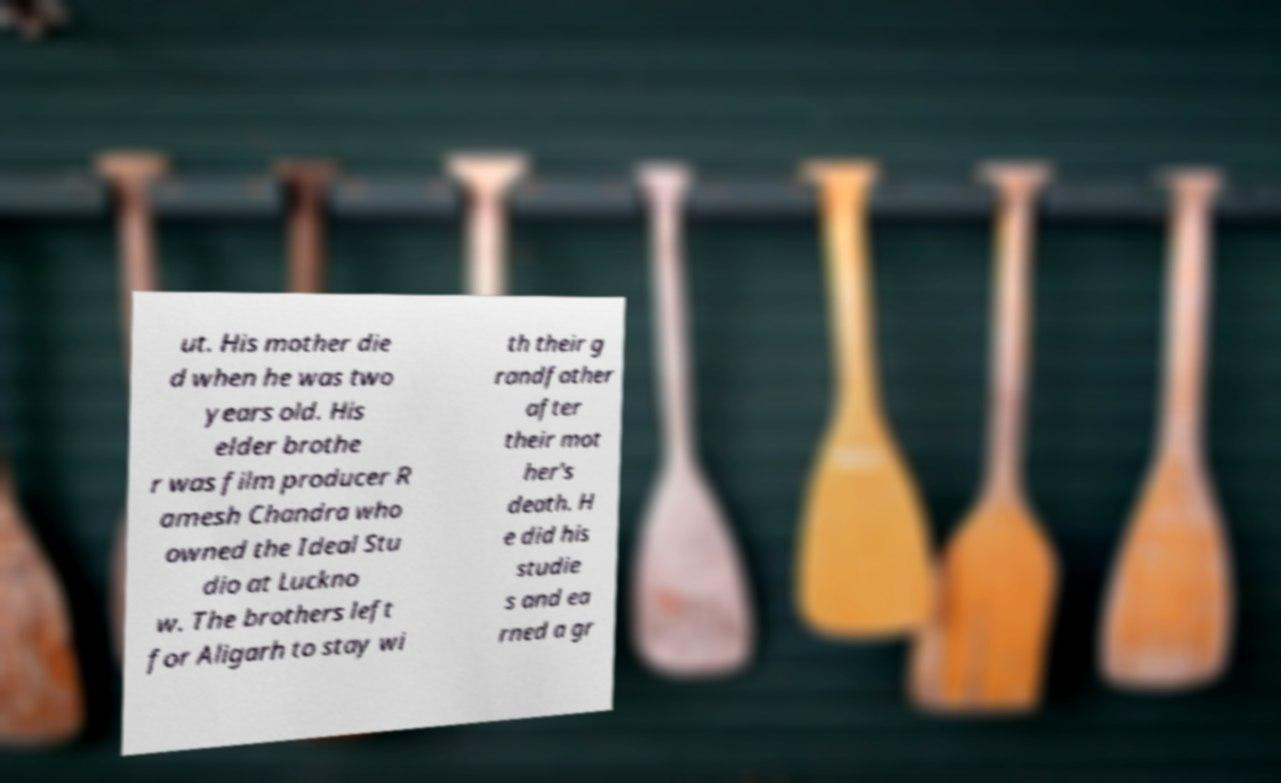What messages or text are displayed in this image? I need them in a readable, typed format. ut. His mother die d when he was two years old. His elder brothe r was film producer R amesh Chandra who owned the Ideal Stu dio at Luckno w. The brothers left for Aligarh to stay wi th their g randfather after their mot her's death. H e did his studie s and ea rned a gr 